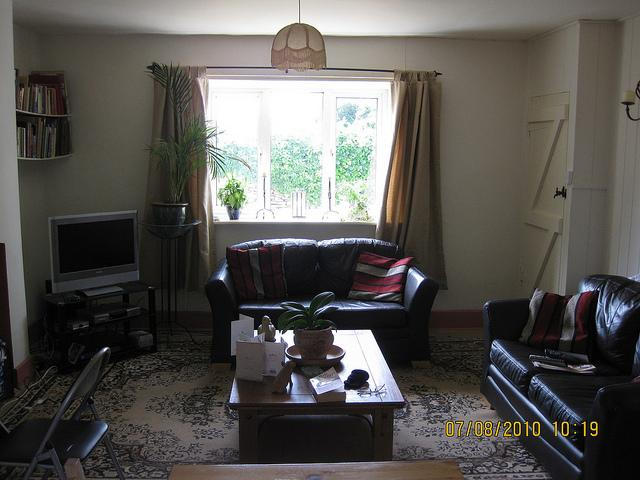What type of plant is on the coffee table?

Choices:
A) begonia
B) orchid
C) violet
D) fern orchid 